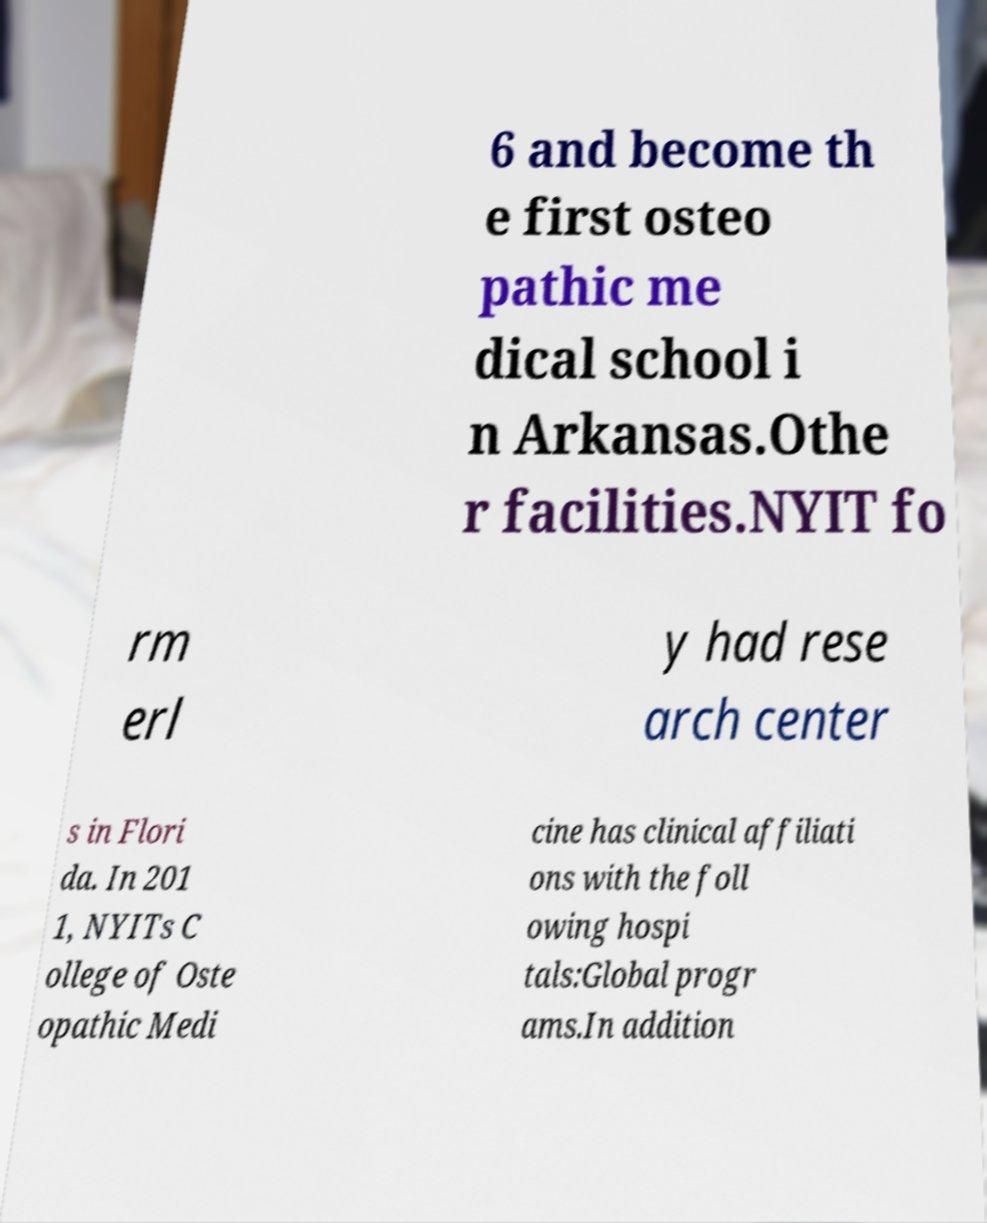Could you extract and type out the text from this image? 6 and become th e first osteo pathic me dical school i n Arkansas.Othe r facilities.NYIT fo rm erl y had rese arch center s in Flori da. In 201 1, NYITs C ollege of Oste opathic Medi cine has clinical affiliati ons with the foll owing hospi tals:Global progr ams.In addition 